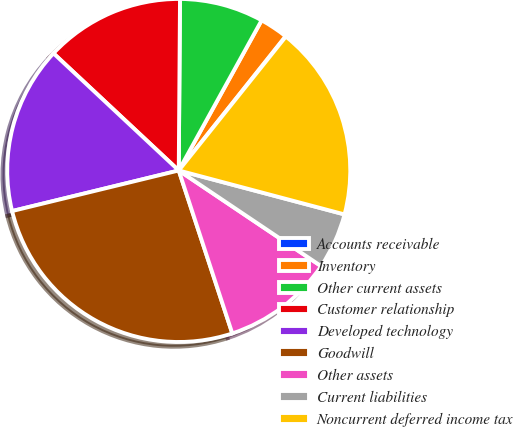<chart> <loc_0><loc_0><loc_500><loc_500><pie_chart><fcel>Accounts receivable<fcel>Inventory<fcel>Other current assets<fcel>Customer relationship<fcel>Developed technology<fcel>Goodwill<fcel>Other assets<fcel>Current liabilities<fcel>Noncurrent deferred income tax<nl><fcel>0.04%<fcel>2.67%<fcel>7.91%<fcel>13.15%<fcel>15.77%<fcel>26.25%<fcel>10.53%<fcel>5.29%<fcel>18.39%<nl></chart> 